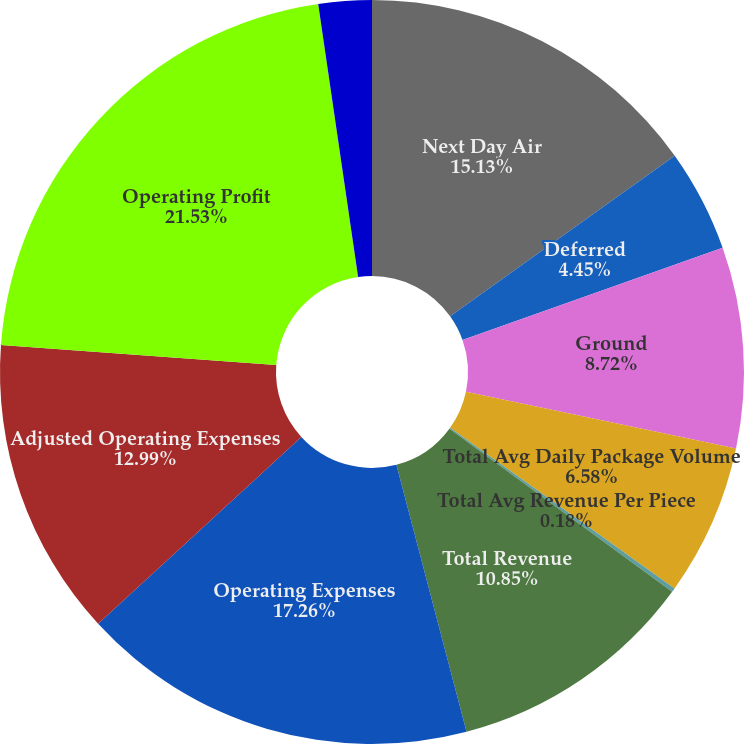Convert chart. <chart><loc_0><loc_0><loc_500><loc_500><pie_chart><fcel>Next Day Air<fcel>Deferred<fcel>Ground<fcel>Total Avg Daily Package Volume<fcel>Total Avg Revenue Per Piece<fcel>Total Revenue<fcel>Operating Expenses<fcel>Adjusted Operating Expenses<fcel>Operating Profit<fcel>Adjusted Operating Profit<nl><fcel>15.13%<fcel>4.45%<fcel>8.72%<fcel>6.58%<fcel>0.18%<fcel>10.85%<fcel>17.26%<fcel>12.99%<fcel>21.53%<fcel>2.31%<nl></chart> 